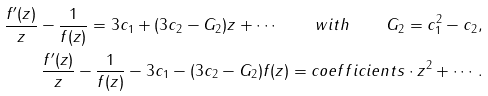<formula> <loc_0><loc_0><loc_500><loc_500>\frac { f ^ { \prime } ( z ) } { z } - \frac { 1 } { f ( z ) } = 3 c _ { 1 } + ( 3 c _ { 2 } - G _ { 2 } ) z + \cdots \quad w i t h \quad G _ { 2 } = c _ { 1 } ^ { 2 } - c _ { 2 } , \\ \frac { f ^ { \prime } ( z ) } { z } - \frac { 1 } { f ( z ) } - 3 c _ { 1 } - ( 3 c _ { 2 } - G _ { 2 } ) f ( z ) = c o e f \/ f \/ i c i e n t s \cdot z ^ { 2 } + \cdots .</formula> 